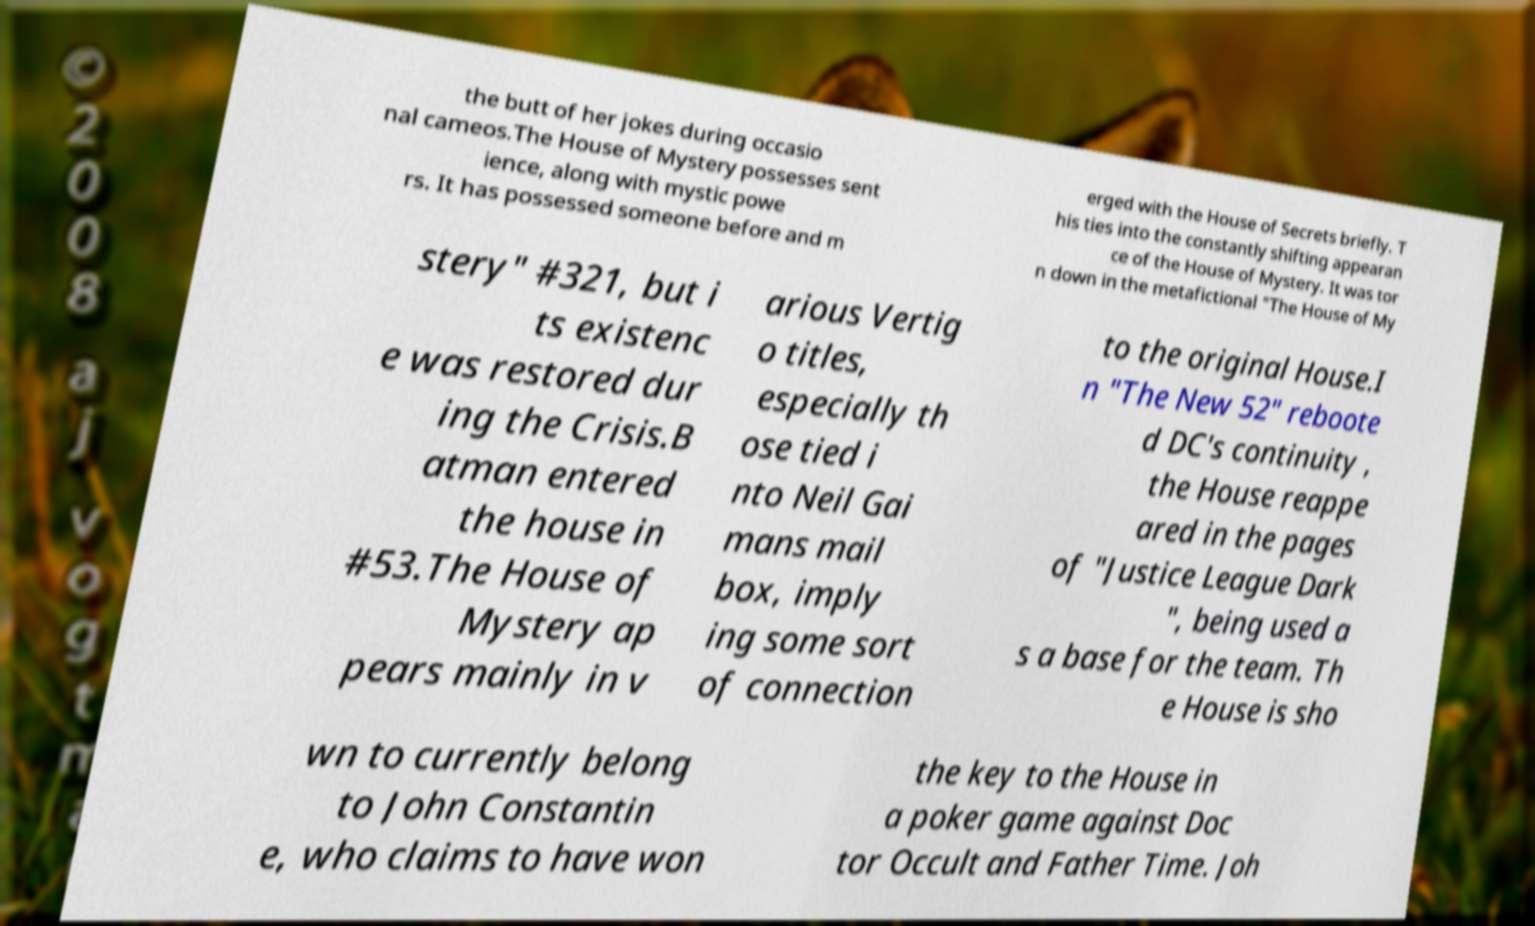Please read and relay the text visible in this image. What does it say? the butt of her jokes during occasio nal cameos.The House of Mystery possesses sent ience, along with mystic powe rs. It has possessed someone before and m erged with the House of Secrets briefly. T his ties into the constantly shifting appearan ce of the House of Mystery. It was tor n down in the metafictional "The House of My stery" #321, but i ts existenc e was restored dur ing the Crisis.B atman entered the house in #53.The House of Mystery ap pears mainly in v arious Vertig o titles, especially th ose tied i nto Neil Gai mans mail box, imply ing some sort of connection to the original House.I n "The New 52" reboote d DC's continuity , the House reappe ared in the pages of "Justice League Dark ", being used a s a base for the team. Th e House is sho wn to currently belong to John Constantin e, who claims to have won the key to the House in a poker game against Doc tor Occult and Father Time. Joh 